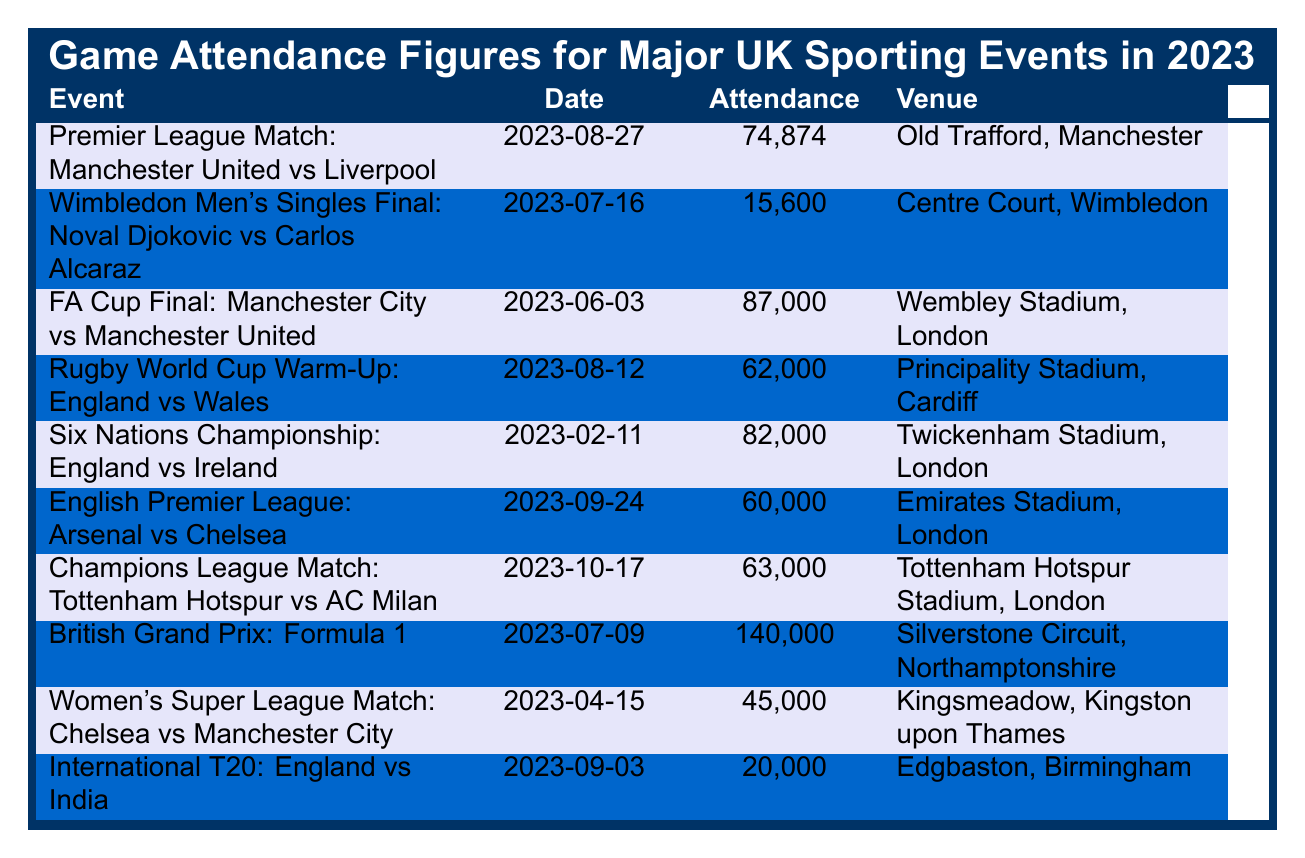What was the highest attendance recorded for a sporting event in 2023? By inspecting the attendance figures listed in the table, the event with the highest attendance is the British Grand Prix: Formula 1 with 140,000 attendees.
Answer: 140,000 What venue hosted the FA Cup Final in 2023? The table lists the FA Cup Final event along with its venue, which is Wembley Stadium, London.
Answer: Wembley Stadium, London Which event had the lowest attendance? Reviewing the attendance figures in the table, the event with the lowest attendance is the Wimbledon Men's Singles Final with 15,600 attendees.
Answer: 15,600 What is the total attendance for all the Rugby events listed? The table shows two Rugby events with attendances of 62,000 (Rugby World Cup Warm-Up) and 82,000 (Six Nations Championship). Summing these gives 62,000 + 82,000 = 144,000.
Answer: 144,000 Did Arsenal vs Chelsea have more attendance than Manchester United vs Liverpool? The attendance for Arsenal vs Chelsea is 60,000, while for Manchester United vs Liverpool, it is 74,874. Since 60,000 is less than 74,874, the answer is no.
Answer: No What was the average attendance for soccer events listed in the table? The soccer events are: Manchester United vs Liverpool (74,874), FA Cup Final (87,000), Arsenal vs Chelsea (60,000), and the Women's Super League match (45,000). The total attendance is 74,874 + 87,000 + 60,000 + 45,000 = 266,874. There are four events, so the average is 266,874 / 4 = 66,718.5.
Answer: 66,718.5 How many more attendees were at the British Grand Prix than at the Wimbledon Men's Singles Final? From the table, the British Grand Prix recorded 140,000 attendees and the Wimbledon Men's Singles Final recorded 15,600. The difference is 140,000 - 15,600 = 124,400.
Answer: 124,400 Which sporting event took place on October 17, 2023? The table lists a Champions League Match: Tottenham Hotspur vs AC Milan occurring on that date.
Answer: Champions League Match: Tottenham Hotspur vs AC Milan Is the attendance for the International T20 match higher than that for the Women's Super League match? The attendance for the International T20 match is 20,000, while for the Women's Super League match it is 45,000. Since 20,000 is less than 45,000, the answer is no.
Answer: No What was the attendance difference between the Six Nations Championship and the Rugby World Cup Warm-Up match? The attendance for the Six Nations Championship is 82,000 and for the Rugby World Cup Warm-Up it is 62,000. The difference is 82,000 - 62,000 = 20,000.
Answer: 20,000 How many events recorded an attendance of over 70,000? By examining the table, the events with over 70,000 attendees are: Premier League Match (74,874), FA Cup Final (87,000), and British Grand Prix (140,000) - a total of three events.
Answer: 3 